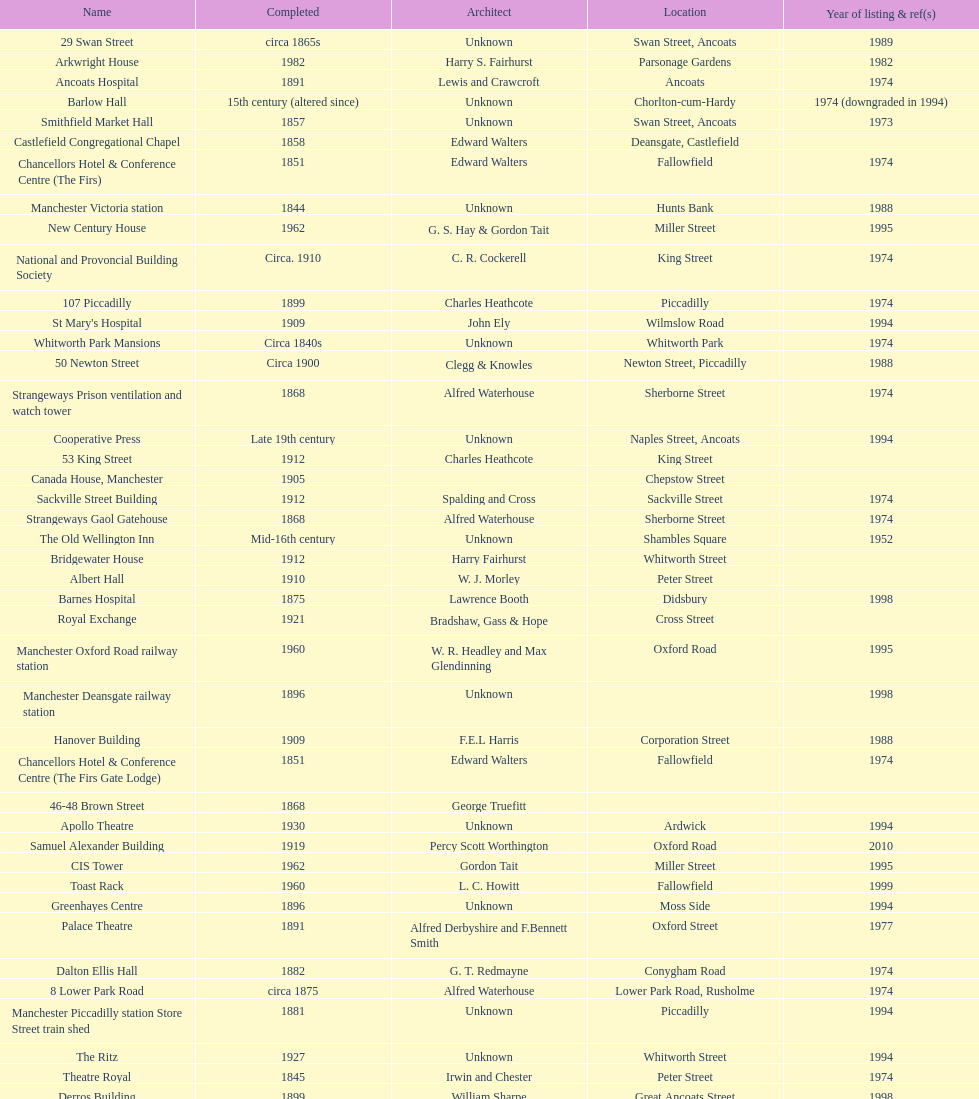Could you parse the entire table as a dict? {'header': ['Name', 'Completed', 'Architect', 'Location', 'Year of listing & ref(s)'], 'rows': [['29 Swan Street', 'circa 1865s', 'Unknown', 'Swan Street, Ancoats', '1989'], ['Arkwright House', '1982', 'Harry S. Fairhurst', 'Parsonage Gardens', '1982'], ['Ancoats Hospital', '1891', 'Lewis and Crawcroft', 'Ancoats', '1974'], ['Barlow Hall', '15th century (altered since)', 'Unknown', 'Chorlton-cum-Hardy', '1974 (downgraded in 1994)'], ['Smithfield Market Hall', '1857', 'Unknown', 'Swan Street, Ancoats', '1973'], ['Castlefield Congregational Chapel', '1858', 'Edward Walters', 'Deansgate, Castlefield', ''], ['Chancellors Hotel & Conference Centre (The Firs)', '1851', 'Edward Walters', 'Fallowfield', '1974'], ['Manchester Victoria station', '1844', 'Unknown', 'Hunts Bank', '1988'], ['New Century House', '1962', 'G. S. Hay & Gordon Tait', 'Miller Street', '1995'], ['National and Provoncial Building Society', 'Circa. 1910', 'C. R. Cockerell', 'King Street', '1974'], ['107 Piccadilly', '1899', 'Charles Heathcote', 'Piccadilly', '1974'], ["St Mary's Hospital", '1909', 'John Ely', 'Wilmslow Road', '1994'], ['Whitworth Park Mansions', 'Circa 1840s', 'Unknown', 'Whitworth Park', '1974'], ['50 Newton Street', 'Circa 1900', 'Clegg & Knowles', 'Newton Street, Piccadilly', '1988'], ['Strangeways Prison ventilation and watch tower', '1868', 'Alfred Waterhouse', 'Sherborne Street', '1974'], ['Cooperative Press', 'Late 19th century', 'Unknown', 'Naples Street, Ancoats', '1994'], ['53 King Street', '1912', 'Charles Heathcote', 'King Street', ''], ['Canada House, Manchester', '1905', '', 'Chepstow Street', ''], ['Sackville Street Building', '1912', 'Spalding and Cross', 'Sackville Street', '1974'], ['Strangeways Gaol Gatehouse', '1868', 'Alfred Waterhouse', 'Sherborne Street', '1974'], ['The Old Wellington Inn', 'Mid-16th century', 'Unknown', 'Shambles Square', '1952'], ['Bridgewater House', '1912', 'Harry Fairhurst', 'Whitworth Street', ''], ['Albert Hall', '1910', 'W. J. Morley', 'Peter Street', ''], ['Barnes Hospital', '1875', 'Lawrence Booth', 'Didsbury', '1998'], ['Royal Exchange', '1921', 'Bradshaw, Gass & Hope', 'Cross Street', ''], ['Manchester Oxford Road railway station', '1960', 'W. R. Headley and Max Glendinning', 'Oxford Road', '1995'], ['Manchester Deansgate railway station', '1896', 'Unknown', '', '1998'], ['Hanover Building', '1909', 'F.E.L Harris', 'Corporation Street', '1988'], ['Chancellors Hotel & Conference Centre (The Firs Gate Lodge)', '1851', 'Edward Walters', 'Fallowfield', '1974'], ['46-48 Brown Street', '1868', 'George Truefitt', '', ''], ['Apollo Theatre', '1930', 'Unknown', 'Ardwick', '1994'], ['Samuel Alexander Building', '1919', 'Percy Scott Worthington', 'Oxford Road', '2010'], ['CIS Tower', '1962', 'Gordon Tait', 'Miller Street', '1995'], ['Toast Rack', '1960', 'L. C. Howitt', 'Fallowfield', '1999'], ['Greenhayes Centre', '1896', 'Unknown', 'Moss Side', '1994'], ['Palace Theatre', '1891', 'Alfred Derbyshire and F.Bennett Smith', 'Oxford Street', '1977'], ['Dalton Ellis Hall', '1882', 'G. T. Redmayne', 'Conygham Road', '1974'], ['8 Lower Park Road', 'circa 1875', 'Alfred Waterhouse', 'Lower Park Road, Rusholme', '1974'], ['Manchester Piccadilly station Store Street train shed', '1881', 'Unknown', 'Piccadilly', '1994'], ['The Ritz', '1927', 'Unknown', 'Whitworth Street', '1994'], ['Theatre Royal', '1845', 'Irwin and Chester', 'Peter Street', '1974'], ['Derros Building', '1899', 'William Sharpe', 'Great Ancoats Street', '1998'], ['1 Booth Street', 'Circa 1850s', 'Unknown', 'Booth Street', '1974'], ['Corn Exchange', '1903', 'Unknown', 'Exchange Square', '1973'], ['St. James Buildings', '1912', 'Clegg, Fryer & Penman', '65-95 Oxford Street', '1988'], ['Ship Canal House', '1927', 'Harry S. Fairhurst', 'King Street', '1982'], ['Redfern Building', '1936', 'W. A. Johnson and J. W. Cooper', 'Dantzic Street', '1994'], ['Manchester Opera House', '1912', 'Richardson and Gill with Farquarson', 'Quay Street', '1974'], ['Holyoake House', '1911', 'F.E.L Harris', 'Dantzic Street', '1988'], ['235-291 Deansgate', '1899', 'Unknown', 'Deansgate', '1988']]} Were ancoats hospital and apollo theatre designed by architect charles heathcote? No. 